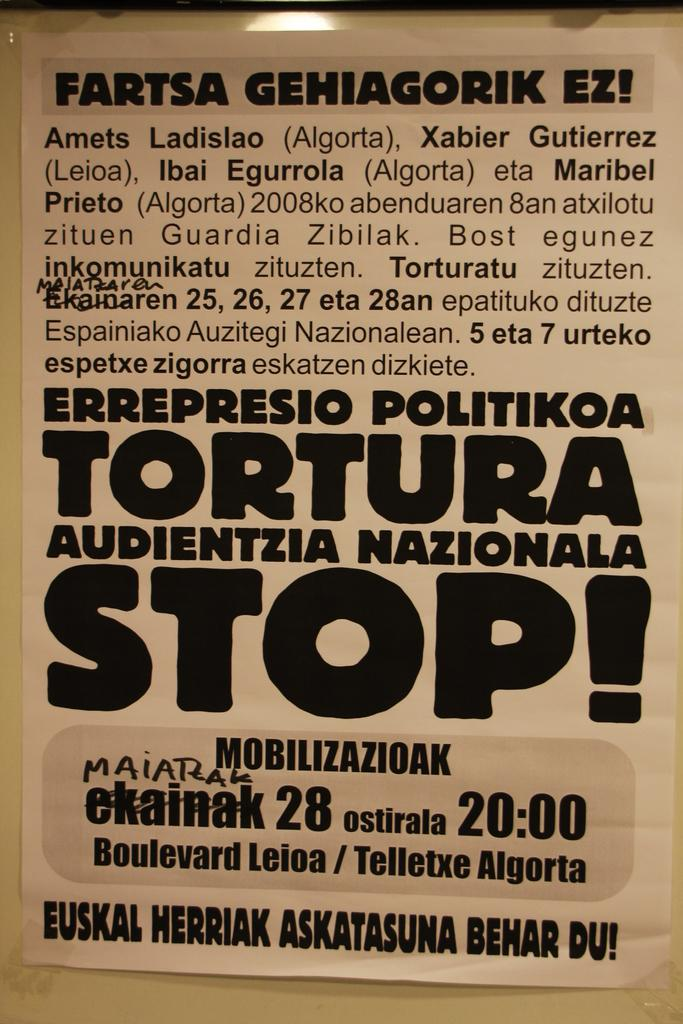What is the main object in the picture? There is a magazine in the picture. What language is the information in the magazine written in? The magazine contains information in Spanish. What type of thread is used to bind the magazine in the image? There is no mention of thread or binding in the provided facts, so it cannot be determined from the image. 